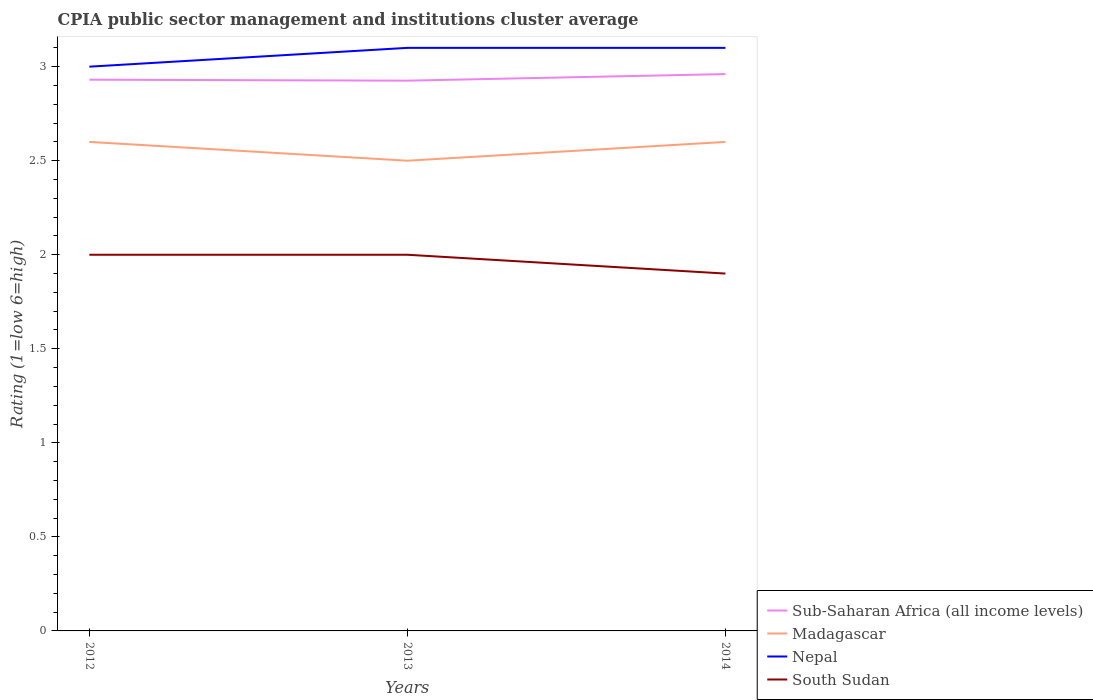Does the line corresponding to Sub-Saharan Africa (all income levels) intersect with the line corresponding to Madagascar?
Ensure brevity in your answer.  No. What is the total CPIA rating in South Sudan in the graph?
Your answer should be compact. 0.1. What is the difference between the highest and the second highest CPIA rating in South Sudan?
Your answer should be compact. 0.1. What is the difference between the highest and the lowest CPIA rating in Madagascar?
Offer a terse response. 2. Does the graph contain any zero values?
Give a very brief answer. No. Does the graph contain grids?
Offer a terse response. No. Where does the legend appear in the graph?
Your answer should be very brief. Bottom right. How are the legend labels stacked?
Your answer should be very brief. Vertical. What is the title of the graph?
Your response must be concise. CPIA public sector management and institutions cluster average. What is the label or title of the Y-axis?
Keep it short and to the point. Rating (1=low 6=high). What is the Rating (1=low 6=high) in Sub-Saharan Africa (all income levels) in 2012?
Offer a very short reply. 2.93. What is the Rating (1=low 6=high) of Madagascar in 2012?
Your answer should be compact. 2.6. What is the Rating (1=low 6=high) of Nepal in 2012?
Your response must be concise. 3. What is the Rating (1=low 6=high) of South Sudan in 2012?
Your answer should be very brief. 2. What is the Rating (1=low 6=high) of Sub-Saharan Africa (all income levels) in 2013?
Provide a short and direct response. 2.93. What is the Rating (1=low 6=high) in Madagascar in 2013?
Make the answer very short. 2.5. What is the Rating (1=low 6=high) of Nepal in 2013?
Provide a succinct answer. 3.1. What is the Rating (1=low 6=high) in South Sudan in 2013?
Offer a terse response. 2. What is the Rating (1=low 6=high) in Sub-Saharan Africa (all income levels) in 2014?
Offer a very short reply. 2.96. What is the Rating (1=low 6=high) of South Sudan in 2014?
Your response must be concise. 1.9. Across all years, what is the maximum Rating (1=low 6=high) in Sub-Saharan Africa (all income levels)?
Provide a short and direct response. 2.96. Across all years, what is the maximum Rating (1=low 6=high) of Madagascar?
Keep it short and to the point. 2.6. Across all years, what is the maximum Rating (1=low 6=high) in Nepal?
Make the answer very short. 3.1. Across all years, what is the maximum Rating (1=low 6=high) in South Sudan?
Give a very brief answer. 2. Across all years, what is the minimum Rating (1=low 6=high) in Sub-Saharan Africa (all income levels)?
Provide a succinct answer. 2.93. Across all years, what is the minimum Rating (1=low 6=high) of Madagascar?
Provide a succinct answer. 2.5. Across all years, what is the minimum Rating (1=low 6=high) of South Sudan?
Ensure brevity in your answer.  1.9. What is the total Rating (1=low 6=high) in Sub-Saharan Africa (all income levels) in the graph?
Your answer should be very brief. 8.82. What is the total Rating (1=low 6=high) of Madagascar in the graph?
Provide a succinct answer. 7.7. What is the total Rating (1=low 6=high) in South Sudan in the graph?
Ensure brevity in your answer.  5.9. What is the difference between the Rating (1=low 6=high) in Sub-Saharan Africa (all income levels) in 2012 and that in 2013?
Keep it short and to the point. 0.01. What is the difference between the Rating (1=low 6=high) of Nepal in 2012 and that in 2013?
Your answer should be very brief. -0.1. What is the difference between the Rating (1=low 6=high) in Sub-Saharan Africa (all income levels) in 2012 and that in 2014?
Keep it short and to the point. -0.03. What is the difference between the Rating (1=low 6=high) of Sub-Saharan Africa (all income levels) in 2013 and that in 2014?
Ensure brevity in your answer.  -0.03. What is the difference between the Rating (1=low 6=high) of Sub-Saharan Africa (all income levels) in 2012 and the Rating (1=low 6=high) of Madagascar in 2013?
Offer a terse response. 0.43. What is the difference between the Rating (1=low 6=high) of Sub-Saharan Africa (all income levels) in 2012 and the Rating (1=low 6=high) of Nepal in 2013?
Offer a terse response. -0.17. What is the difference between the Rating (1=low 6=high) of Sub-Saharan Africa (all income levels) in 2012 and the Rating (1=low 6=high) of South Sudan in 2013?
Keep it short and to the point. 0.93. What is the difference between the Rating (1=low 6=high) in Sub-Saharan Africa (all income levels) in 2012 and the Rating (1=low 6=high) in Madagascar in 2014?
Provide a succinct answer. 0.33. What is the difference between the Rating (1=low 6=high) of Sub-Saharan Africa (all income levels) in 2012 and the Rating (1=low 6=high) of Nepal in 2014?
Keep it short and to the point. -0.17. What is the difference between the Rating (1=low 6=high) of Sub-Saharan Africa (all income levels) in 2012 and the Rating (1=low 6=high) of South Sudan in 2014?
Offer a terse response. 1.03. What is the difference between the Rating (1=low 6=high) in Sub-Saharan Africa (all income levels) in 2013 and the Rating (1=low 6=high) in Madagascar in 2014?
Ensure brevity in your answer.  0.33. What is the difference between the Rating (1=low 6=high) in Sub-Saharan Africa (all income levels) in 2013 and the Rating (1=low 6=high) in Nepal in 2014?
Your answer should be compact. -0.17. What is the difference between the Rating (1=low 6=high) of Sub-Saharan Africa (all income levels) in 2013 and the Rating (1=low 6=high) of South Sudan in 2014?
Offer a terse response. 1.03. What is the difference between the Rating (1=low 6=high) of Nepal in 2013 and the Rating (1=low 6=high) of South Sudan in 2014?
Make the answer very short. 1.2. What is the average Rating (1=low 6=high) in Sub-Saharan Africa (all income levels) per year?
Ensure brevity in your answer.  2.94. What is the average Rating (1=low 6=high) of Madagascar per year?
Provide a succinct answer. 2.57. What is the average Rating (1=low 6=high) of Nepal per year?
Make the answer very short. 3.07. What is the average Rating (1=low 6=high) of South Sudan per year?
Your answer should be compact. 1.97. In the year 2012, what is the difference between the Rating (1=low 6=high) of Sub-Saharan Africa (all income levels) and Rating (1=low 6=high) of Madagascar?
Your answer should be very brief. 0.33. In the year 2012, what is the difference between the Rating (1=low 6=high) in Sub-Saharan Africa (all income levels) and Rating (1=low 6=high) in Nepal?
Give a very brief answer. -0.07. In the year 2012, what is the difference between the Rating (1=low 6=high) of Sub-Saharan Africa (all income levels) and Rating (1=low 6=high) of South Sudan?
Your answer should be compact. 0.93. In the year 2012, what is the difference between the Rating (1=low 6=high) of Madagascar and Rating (1=low 6=high) of South Sudan?
Provide a succinct answer. 0.6. In the year 2012, what is the difference between the Rating (1=low 6=high) in Nepal and Rating (1=low 6=high) in South Sudan?
Your response must be concise. 1. In the year 2013, what is the difference between the Rating (1=low 6=high) of Sub-Saharan Africa (all income levels) and Rating (1=low 6=high) of Madagascar?
Ensure brevity in your answer.  0.43. In the year 2013, what is the difference between the Rating (1=low 6=high) in Sub-Saharan Africa (all income levels) and Rating (1=low 6=high) in Nepal?
Provide a succinct answer. -0.17. In the year 2013, what is the difference between the Rating (1=low 6=high) in Sub-Saharan Africa (all income levels) and Rating (1=low 6=high) in South Sudan?
Your answer should be compact. 0.93. In the year 2013, what is the difference between the Rating (1=low 6=high) of Madagascar and Rating (1=low 6=high) of South Sudan?
Keep it short and to the point. 0.5. In the year 2013, what is the difference between the Rating (1=low 6=high) of Nepal and Rating (1=low 6=high) of South Sudan?
Your answer should be compact. 1.1. In the year 2014, what is the difference between the Rating (1=low 6=high) of Sub-Saharan Africa (all income levels) and Rating (1=low 6=high) of Madagascar?
Your answer should be very brief. 0.36. In the year 2014, what is the difference between the Rating (1=low 6=high) of Sub-Saharan Africa (all income levels) and Rating (1=low 6=high) of Nepal?
Give a very brief answer. -0.14. In the year 2014, what is the difference between the Rating (1=low 6=high) of Sub-Saharan Africa (all income levels) and Rating (1=low 6=high) of South Sudan?
Offer a very short reply. 1.06. In the year 2014, what is the difference between the Rating (1=low 6=high) in Madagascar and Rating (1=low 6=high) in Nepal?
Make the answer very short. -0.5. In the year 2014, what is the difference between the Rating (1=low 6=high) in Madagascar and Rating (1=low 6=high) in South Sudan?
Offer a terse response. 0.7. What is the ratio of the Rating (1=low 6=high) in Sub-Saharan Africa (all income levels) in 2012 to that in 2013?
Offer a terse response. 1. What is the ratio of the Rating (1=low 6=high) in Nepal in 2012 to that in 2013?
Keep it short and to the point. 0.97. What is the ratio of the Rating (1=low 6=high) in South Sudan in 2012 to that in 2013?
Make the answer very short. 1. What is the ratio of the Rating (1=low 6=high) in Sub-Saharan Africa (all income levels) in 2012 to that in 2014?
Your answer should be compact. 0.99. What is the ratio of the Rating (1=low 6=high) of Madagascar in 2012 to that in 2014?
Offer a terse response. 1. What is the ratio of the Rating (1=low 6=high) in Nepal in 2012 to that in 2014?
Ensure brevity in your answer.  0.97. What is the ratio of the Rating (1=low 6=high) of South Sudan in 2012 to that in 2014?
Provide a succinct answer. 1.05. What is the ratio of the Rating (1=low 6=high) of Sub-Saharan Africa (all income levels) in 2013 to that in 2014?
Your answer should be compact. 0.99. What is the ratio of the Rating (1=low 6=high) of Madagascar in 2013 to that in 2014?
Provide a short and direct response. 0.96. What is the ratio of the Rating (1=low 6=high) in Nepal in 2013 to that in 2014?
Offer a very short reply. 1. What is the ratio of the Rating (1=low 6=high) of South Sudan in 2013 to that in 2014?
Your response must be concise. 1.05. What is the difference between the highest and the second highest Rating (1=low 6=high) in Sub-Saharan Africa (all income levels)?
Offer a terse response. 0.03. What is the difference between the highest and the second highest Rating (1=low 6=high) in South Sudan?
Make the answer very short. 0. What is the difference between the highest and the lowest Rating (1=low 6=high) in Sub-Saharan Africa (all income levels)?
Keep it short and to the point. 0.03. What is the difference between the highest and the lowest Rating (1=low 6=high) in Nepal?
Provide a succinct answer. 0.1. 